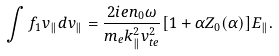Convert formula to latex. <formula><loc_0><loc_0><loc_500><loc_500>\int f _ { 1 } v _ { \| } d v _ { \| } = \frac { 2 i e n _ { 0 } \omega } { m _ { e } k ^ { 2 } _ { \| } v _ { t e } ^ { 2 } } [ 1 + \alpha Z _ { 0 } ( \alpha ) ] E _ { \| } .</formula> 